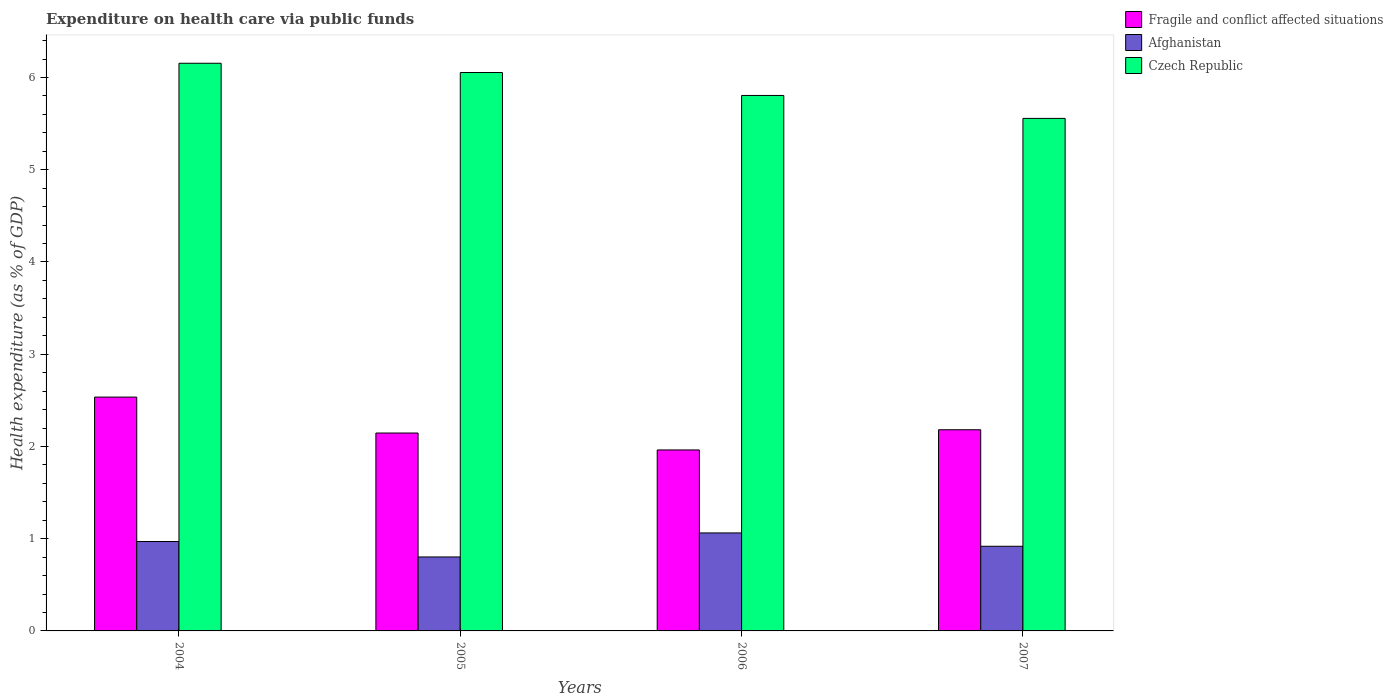Are the number of bars per tick equal to the number of legend labels?
Your answer should be compact. Yes. How many bars are there on the 4th tick from the left?
Ensure brevity in your answer.  3. In how many cases, is the number of bars for a given year not equal to the number of legend labels?
Provide a succinct answer. 0. What is the expenditure made on health care in Afghanistan in 2006?
Offer a very short reply. 1.06. Across all years, what is the maximum expenditure made on health care in Afghanistan?
Your response must be concise. 1.06. Across all years, what is the minimum expenditure made on health care in Czech Republic?
Make the answer very short. 5.56. In which year was the expenditure made on health care in Czech Republic minimum?
Your answer should be very brief. 2007. What is the total expenditure made on health care in Afghanistan in the graph?
Keep it short and to the point. 3.75. What is the difference between the expenditure made on health care in Czech Republic in 2004 and that in 2006?
Ensure brevity in your answer.  0.35. What is the difference between the expenditure made on health care in Fragile and conflict affected situations in 2007 and the expenditure made on health care in Afghanistan in 2006?
Your answer should be very brief. 1.12. What is the average expenditure made on health care in Afghanistan per year?
Offer a terse response. 0.94. In the year 2006, what is the difference between the expenditure made on health care in Czech Republic and expenditure made on health care in Afghanistan?
Keep it short and to the point. 4.74. In how many years, is the expenditure made on health care in Fragile and conflict affected situations greater than 2 %?
Make the answer very short. 3. What is the ratio of the expenditure made on health care in Czech Republic in 2004 to that in 2007?
Make the answer very short. 1.11. What is the difference between the highest and the second highest expenditure made on health care in Afghanistan?
Your response must be concise. 0.09. What is the difference between the highest and the lowest expenditure made on health care in Czech Republic?
Make the answer very short. 0.6. In how many years, is the expenditure made on health care in Afghanistan greater than the average expenditure made on health care in Afghanistan taken over all years?
Give a very brief answer. 2. Is the sum of the expenditure made on health care in Czech Republic in 2005 and 2007 greater than the maximum expenditure made on health care in Fragile and conflict affected situations across all years?
Provide a short and direct response. Yes. What does the 2nd bar from the left in 2006 represents?
Make the answer very short. Afghanistan. What does the 2nd bar from the right in 2006 represents?
Offer a very short reply. Afghanistan. Does the graph contain any zero values?
Ensure brevity in your answer.  No. Where does the legend appear in the graph?
Provide a short and direct response. Top right. How are the legend labels stacked?
Your answer should be very brief. Vertical. What is the title of the graph?
Make the answer very short. Expenditure on health care via public funds. What is the label or title of the X-axis?
Offer a very short reply. Years. What is the label or title of the Y-axis?
Provide a succinct answer. Health expenditure (as % of GDP). What is the Health expenditure (as % of GDP) of Fragile and conflict affected situations in 2004?
Ensure brevity in your answer.  2.54. What is the Health expenditure (as % of GDP) of Afghanistan in 2004?
Your answer should be very brief. 0.97. What is the Health expenditure (as % of GDP) in Czech Republic in 2004?
Make the answer very short. 6.15. What is the Health expenditure (as % of GDP) of Fragile and conflict affected situations in 2005?
Make the answer very short. 2.15. What is the Health expenditure (as % of GDP) in Afghanistan in 2005?
Offer a very short reply. 0.8. What is the Health expenditure (as % of GDP) of Czech Republic in 2005?
Provide a succinct answer. 6.05. What is the Health expenditure (as % of GDP) in Fragile and conflict affected situations in 2006?
Your answer should be very brief. 1.96. What is the Health expenditure (as % of GDP) in Afghanistan in 2006?
Ensure brevity in your answer.  1.06. What is the Health expenditure (as % of GDP) in Czech Republic in 2006?
Ensure brevity in your answer.  5.81. What is the Health expenditure (as % of GDP) of Fragile and conflict affected situations in 2007?
Offer a very short reply. 2.18. What is the Health expenditure (as % of GDP) of Afghanistan in 2007?
Provide a short and direct response. 0.92. What is the Health expenditure (as % of GDP) in Czech Republic in 2007?
Keep it short and to the point. 5.56. Across all years, what is the maximum Health expenditure (as % of GDP) in Fragile and conflict affected situations?
Your answer should be very brief. 2.54. Across all years, what is the maximum Health expenditure (as % of GDP) of Afghanistan?
Ensure brevity in your answer.  1.06. Across all years, what is the maximum Health expenditure (as % of GDP) of Czech Republic?
Your response must be concise. 6.15. Across all years, what is the minimum Health expenditure (as % of GDP) in Fragile and conflict affected situations?
Offer a terse response. 1.96. Across all years, what is the minimum Health expenditure (as % of GDP) of Afghanistan?
Make the answer very short. 0.8. Across all years, what is the minimum Health expenditure (as % of GDP) of Czech Republic?
Your answer should be compact. 5.56. What is the total Health expenditure (as % of GDP) of Fragile and conflict affected situations in the graph?
Provide a succinct answer. 8.82. What is the total Health expenditure (as % of GDP) in Afghanistan in the graph?
Keep it short and to the point. 3.75. What is the total Health expenditure (as % of GDP) of Czech Republic in the graph?
Offer a very short reply. 23.57. What is the difference between the Health expenditure (as % of GDP) in Fragile and conflict affected situations in 2004 and that in 2005?
Offer a very short reply. 0.39. What is the difference between the Health expenditure (as % of GDP) of Afghanistan in 2004 and that in 2005?
Your answer should be very brief. 0.17. What is the difference between the Health expenditure (as % of GDP) of Czech Republic in 2004 and that in 2005?
Give a very brief answer. 0.1. What is the difference between the Health expenditure (as % of GDP) in Fragile and conflict affected situations in 2004 and that in 2006?
Your answer should be very brief. 0.57. What is the difference between the Health expenditure (as % of GDP) of Afghanistan in 2004 and that in 2006?
Offer a terse response. -0.09. What is the difference between the Health expenditure (as % of GDP) in Czech Republic in 2004 and that in 2006?
Your answer should be very brief. 0.35. What is the difference between the Health expenditure (as % of GDP) in Fragile and conflict affected situations in 2004 and that in 2007?
Offer a very short reply. 0.35. What is the difference between the Health expenditure (as % of GDP) in Afghanistan in 2004 and that in 2007?
Offer a terse response. 0.05. What is the difference between the Health expenditure (as % of GDP) of Czech Republic in 2004 and that in 2007?
Provide a short and direct response. 0.6. What is the difference between the Health expenditure (as % of GDP) of Fragile and conflict affected situations in 2005 and that in 2006?
Provide a succinct answer. 0.18. What is the difference between the Health expenditure (as % of GDP) of Afghanistan in 2005 and that in 2006?
Offer a very short reply. -0.26. What is the difference between the Health expenditure (as % of GDP) of Czech Republic in 2005 and that in 2006?
Ensure brevity in your answer.  0.25. What is the difference between the Health expenditure (as % of GDP) of Fragile and conflict affected situations in 2005 and that in 2007?
Provide a succinct answer. -0.04. What is the difference between the Health expenditure (as % of GDP) of Afghanistan in 2005 and that in 2007?
Keep it short and to the point. -0.12. What is the difference between the Health expenditure (as % of GDP) of Czech Republic in 2005 and that in 2007?
Offer a terse response. 0.5. What is the difference between the Health expenditure (as % of GDP) in Fragile and conflict affected situations in 2006 and that in 2007?
Keep it short and to the point. -0.22. What is the difference between the Health expenditure (as % of GDP) of Afghanistan in 2006 and that in 2007?
Make the answer very short. 0.14. What is the difference between the Health expenditure (as % of GDP) in Czech Republic in 2006 and that in 2007?
Give a very brief answer. 0.25. What is the difference between the Health expenditure (as % of GDP) in Fragile and conflict affected situations in 2004 and the Health expenditure (as % of GDP) in Afghanistan in 2005?
Provide a succinct answer. 1.73. What is the difference between the Health expenditure (as % of GDP) in Fragile and conflict affected situations in 2004 and the Health expenditure (as % of GDP) in Czech Republic in 2005?
Keep it short and to the point. -3.52. What is the difference between the Health expenditure (as % of GDP) in Afghanistan in 2004 and the Health expenditure (as % of GDP) in Czech Republic in 2005?
Make the answer very short. -5.08. What is the difference between the Health expenditure (as % of GDP) of Fragile and conflict affected situations in 2004 and the Health expenditure (as % of GDP) of Afghanistan in 2006?
Provide a succinct answer. 1.47. What is the difference between the Health expenditure (as % of GDP) in Fragile and conflict affected situations in 2004 and the Health expenditure (as % of GDP) in Czech Republic in 2006?
Ensure brevity in your answer.  -3.27. What is the difference between the Health expenditure (as % of GDP) in Afghanistan in 2004 and the Health expenditure (as % of GDP) in Czech Republic in 2006?
Ensure brevity in your answer.  -4.84. What is the difference between the Health expenditure (as % of GDP) of Fragile and conflict affected situations in 2004 and the Health expenditure (as % of GDP) of Afghanistan in 2007?
Your answer should be very brief. 1.62. What is the difference between the Health expenditure (as % of GDP) of Fragile and conflict affected situations in 2004 and the Health expenditure (as % of GDP) of Czech Republic in 2007?
Your response must be concise. -3.02. What is the difference between the Health expenditure (as % of GDP) in Afghanistan in 2004 and the Health expenditure (as % of GDP) in Czech Republic in 2007?
Offer a terse response. -4.59. What is the difference between the Health expenditure (as % of GDP) in Fragile and conflict affected situations in 2005 and the Health expenditure (as % of GDP) in Afghanistan in 2006?
Provide a succinct answer. 1.08. What is the difference between the Health expenditure (as % of GDP) in Fragile and conflict affected situations in 2005 and the Health expenditure (as % of GDP) in Czech Republic in 2006?
Your answer should be compact. -3.66. What is the difference between the Health expenditure (as % of GDP) of Afghanistan in 2005 and the Health expenditure (as % of GDP) of Czech Republic in 2006?
Keep it short and to the point. -5. What is the difference between the Health expenditure (as % of GDP) in Fragile and conflict affected situations in 2005 and the Health expenditure (as % of GDP) in Afghanistan in 2007?
Ensure brevity in your answer.  1.23. What is the difference between the Health expenditure (as % of GDP) in Fragile and conflict affected situations in 2005 and the Health expenditure (as % of GDP) in Czech Republic in 2007?
Your response must be concise. -3.41. What is the difference between the Health expenditure (as % of GDP) in Afghanistan in 2005 and the Health expenditure (as % of GDP) in Czech Republic in 2007?
Your response must be concise. -4.75. What is the difference between the Health expenditure (as % of GDP) of Fragile and conflict affected situations in 2006 and the Health expenditure (as % of GDP) of Afghanistan in 2007?
Keep it short and to the point. 1.04. What is the difference between the Health expenditure (as % of GDP) in Fragile and conflict affected situations in 2006 and the Health expenditure (as % of GDP) in Czech Republic in 2007?
Provide a short and direct response. -3.59. What is the difference between the Health expenditure (as % of GDP) of Afghanistan in 2006 and the Health expenditure (as % of GDP) of Czech Republic in 2007?
Your response must be concise. -4.49. What is the average Health expenditure (as % of GDP) of Fragile and conflict affected situations per year?
Your answer should be compact. 2.21. What is the average Health expenditure (as % of GDP) of Afghanistan per year?
Offer a very short reply. 0.94. What is the average Health expenditure (as % of GDP) in Czech Republic per year?
Provide a short and direct response. 5.89. In the year 2004, what is the difference between the Health expenditure (as % of GDP) in Fragile and conflict affected situations and Health expenditure (as % of GDP) in Afghanistan?
Provide a succinct answer. 1.57. In the year 2004, what is the difference between the Health expenditure (as % of GDP) in Fragile and conflict affected situations and Health expenditure (as % of GDP) in Czech Republic?
Make the answer very short. -3.62. In the year 2004, what is the difference between the Health expenditure (as % of GDP) of Afghanistan and Health expenditure (as % of GDP) of Czech Republic?
Your answer should be compact. -5.18. In the year 2005, what is the difference between the Health expenditure (as % of GDP) in Fragile and conflict affected situations and Health expenditure (as % of GDP) in Afghanistan?
Give a very brief answer. 1.34. In the year 2005, what is the difference between the Health expenditure (as % of GDP) in Fragile and conflict affected situations and Health expenditure (as % of GDP) in Czech Republic?
Offer a terse response. -3.91. In the year 2005, what is the difference between the Health expenditure (as % of GDP) of Afghanistan and Health expenditure (as % of GDP) of Czech Republic?
Give a very brief answer. -5.25. In the year 2006, what is the difference between the Health expenditure (as % of GDP) of Fragile and conflict affected situations and Health expenditure (as % of GDP) of Afghanistan?
Make the answer very short. 0.9. In the year 2006, what is the difference between the Health expenditure (as % of GDP) in Fragile and conflict affected situations and Health expenditure (as % of GDP) in Czech Republic?
Offer a terse response. -3.84. In the year 2006, what is the difference between the Health expenditure (as % of GDP) of Afghanistan and Health expenditure (as % of GDP) of Czech Republic?
Give a very brief answer. -4.74. In the year 2007, what is the difference between the Health expenditure (as % of GDP) in Fragile and conflict affected situations and Health expenditure (as % of GDP) in Afghanistan?
Offer a terse response. 1.26. In the year 2007, what is the difference between the Health expenditure (as % of GDP) of Fragile and conflict affected situations and Health expenditure (as % of GDP) of Czech Republic?
Make the answer very short. -3.38. In the year 2007, what is the difference between the Health expenditure (as % of GDP) in Afghanistan and Health expenditure (as % of GDP) in Czech Republic?
Offer a terse response. -4.64. What is the ratio of the Health expenditure (as % of GDP) of Fragile and conflict affected situations in 2004 to that in 2005?
Ensure brevity in your answer.  1.18. What is the ratio of the Health expenditure (as % of GDP) in Afghanistan in 2004 to that in 2005?
Keep it short and to the point. 1.21. What is the ratio of the Health expenditure (as % of GDP) in Czech Republic in 2004 to that in 2005?
Offer a terse response. 1.02. What is the ratio of the Health expenditure (as % of GDP) of Fragile and conflict affected situations in 2004 to that in 2006?
Provide a succinct answer. 1.29. What is the ratio of the Health expenditure (as % of GDP) in Afghanistan in 2004 to that in 2006?
Provide a short and direct response. 0.91. What is the ratio of the Health expenditure (as % of GDP) in Czech Republic in 2004 to that in 2006?
Offer a terse response. 1.06. What is the ratio of the Health expenditure (as % of GDP) of Fragile and conflict affected situations in 2004 to that in 2007?
Your answer should be compact. 1.16. What is the ratio of the Health expenditure (as % of GDP) of Afghanistan in 2004 to that in 2007?
Give a very brief answer. 1.06. What is the ratio of the Health expenditure (as % of GDP) in Czech Republic in 2004 to that in 2007?
Keep it short and to the point. 1.11. What is the ratio of the Health expenditure (as % of GDP) of Fragile and conflict affected situations in 2005 to that in 2006?
Make the answer very short. 1.09. What is the ratio of the Health expenditure (as % of GDP) of Afghanistan in 2005 to that in 2006?
Make the answer very short. 0.75. What is the ratio of the Health expenditure (as % of GDP) in Czech Republic in 2005 to that in 2006?
Make the answer very short. 1.04. What is the ratio of the Health expenditure (as % of GDP) of Fragile and conflict affected situations in 2005 to that in 2007?
Keep it short and to the point. 0.98. What is the ratio of the Health expenditure (as % of GDP) in Afghanistan in 2005 to that in 2007?
Provide a short and direct response. 0.87. What is the ratio of the Health expenditure (as % of GDP) in Czech Republic in 2005 to that in 2007?
Ensure brevity in your answer.  1.09. What is the ratio of the Health expenditure (as % of GDP) of Fragile and conflict affected situations in 2006 to that in 2007?
Give a very brief answer. 0.9. What is the ratio of the Health expenditure (as % of GDP) in Afghanistan in 2006 to that in 2007?
Give a very brief answer. 1.16. What is the ratio of the Health expenditure (as % of GDP) in Czech Republic in 2006 to that in 2007?
Keep it short and to the point. 1.04. What is the difference between the highest and the second highest Health expenditure (as % of GDP) in Fragile and conflict affected situations?
Your answer should be very brief. 0.35. What is the difference between the highest and the second highest Health expenditure (as % of GDP) of Afghanistan?
Keep it short and to the point. 0.09. What is the difference between the highest and the second highest Health expenditure (as % of GDP) in Czech Republic?
Offer a very short reply. 0.1. What is the difference between the highest and the lowest Health expenditure (as % of GDP) of Fragile and conflict affected situations?
Your response must be concise. 0.57. What is the difference between the highest and the lowest Health expenditure (as % of GDP) in Afghanistan?
Your answer should be compact. 0.26. What is the difference between the highest and the lowest Health expenditure (as % of GDP) of Czech Republic?
Ensure brevity in your answer.  0.6. 